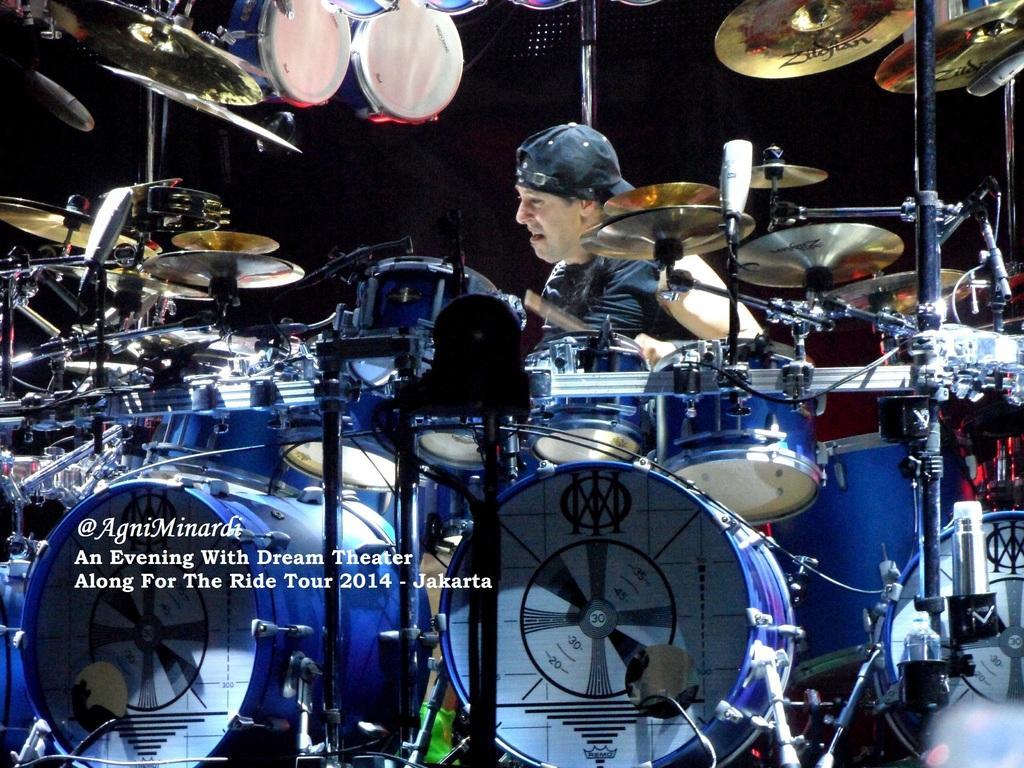Can you describe this image briefly? In this picture we can see musical instruments, some text and a man wore a cap and in the background it is dark. 